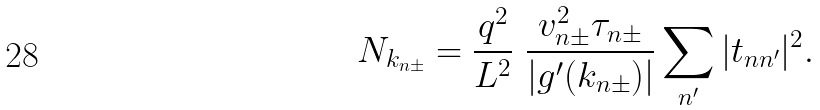Convert formula to latex. <formula><loc_0><loc_0><loc_500><loc_500>N _ { k _ { n \pm } } = \frac { q ^ { 2 } } { L ^ { 2 } } \ \frac { v _ { n \pm } ^ { 2 } \tau _ { n \pm } } { | g ^ { \prime } ( k _ { n \pm } ) | } \sum _ { n ^ { \prime } } | t _ { n n ^ { \prime } } | ^ { 2 } .</formula> 